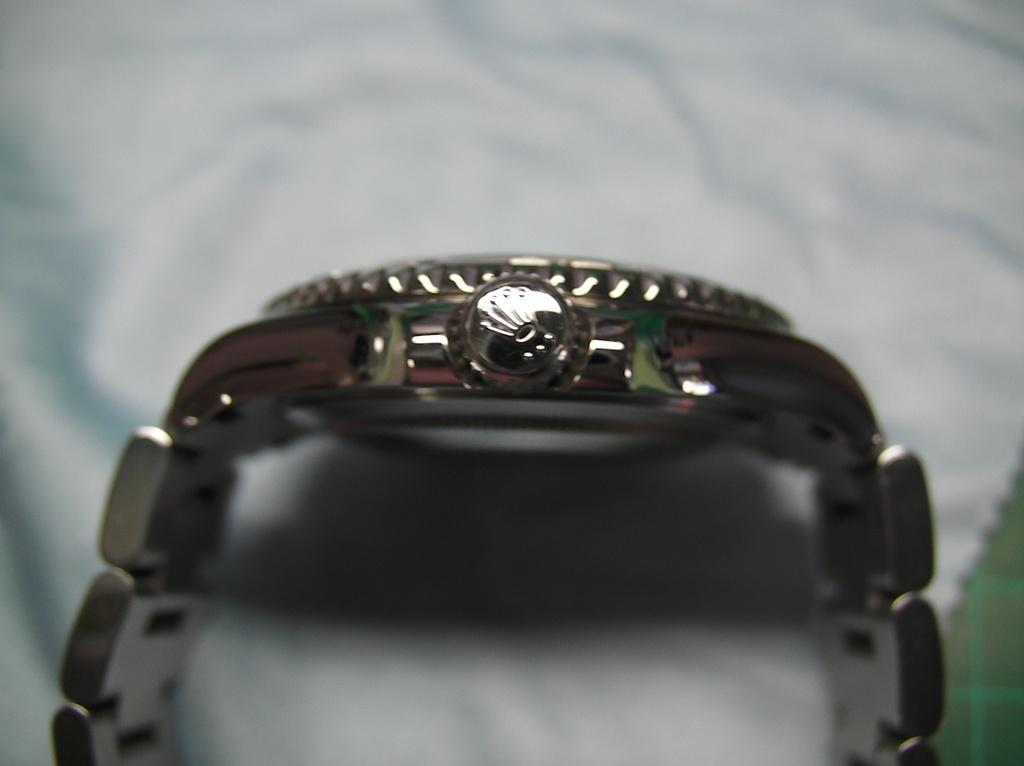Describe this image in one or two sentences. In this image I can see the watch which is in silver color. It is on the white color surface. 